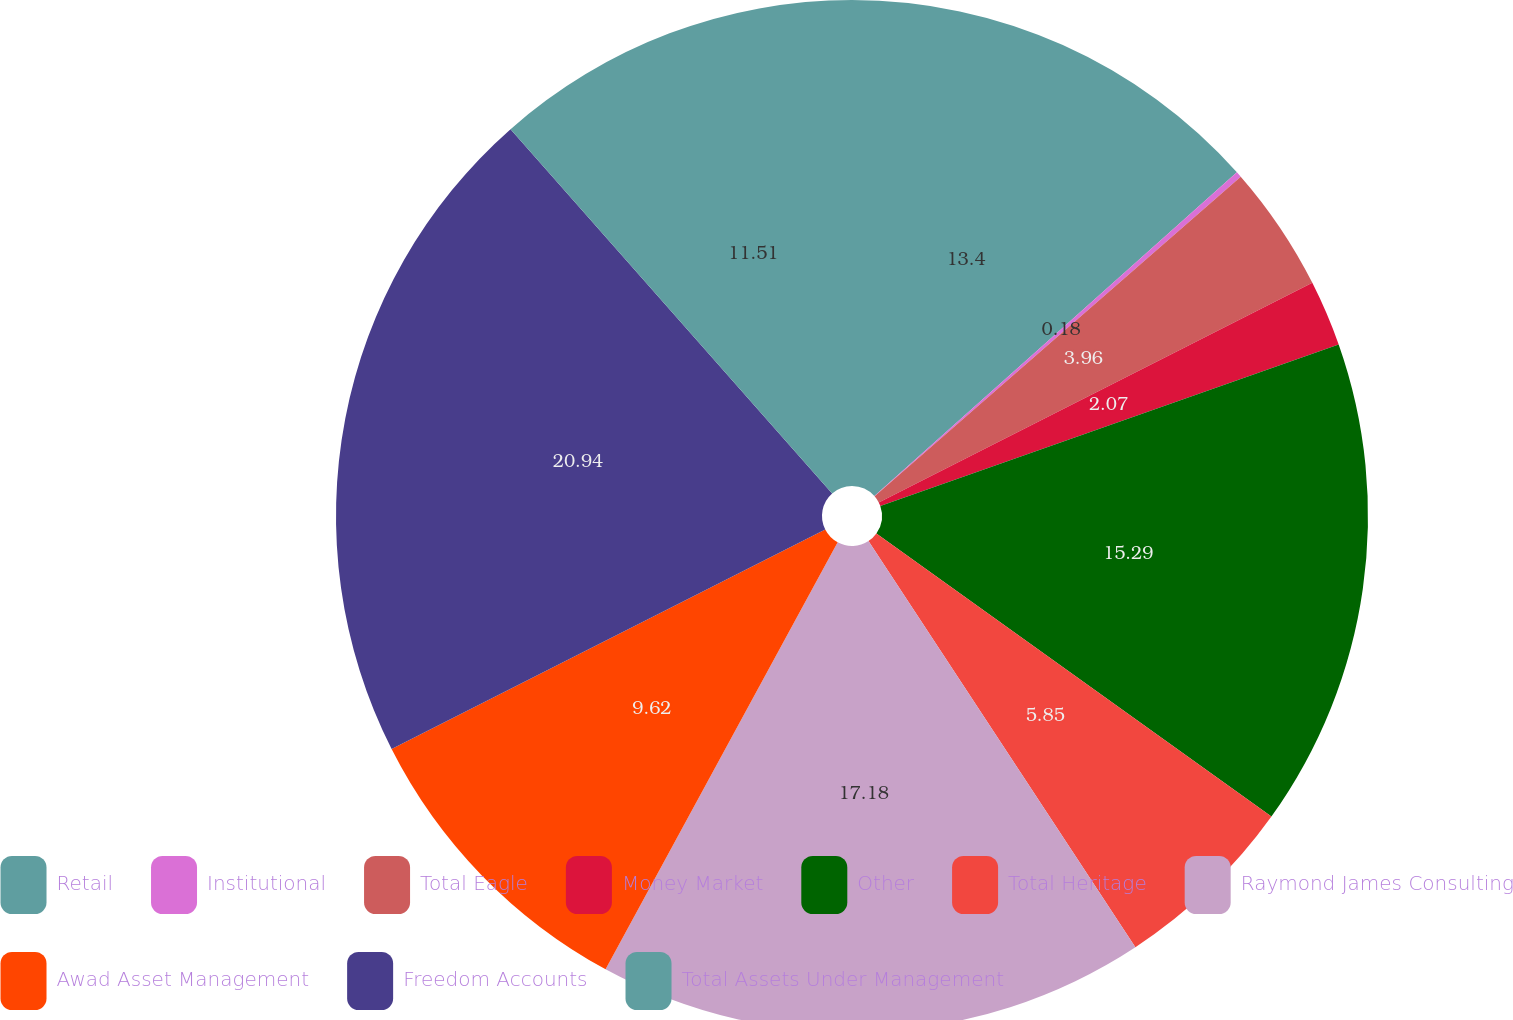Convert chart. <chart><loc_0><loc_0><loc_500><loc_500><pie_chart><fcel>Retail<fcel>Institutional<fcel>Total Eagle<fcel>Money Market<fcel>Other<fcel>Total Heritage<fcel>Raymond James Consulting<fcel>Awad Asset Management<fcel>Freedom Accounts<fcel>Total Assets Under Management<nl><fcel>13.4%<fcel>0.18%<fcel>3.96%<fcel>2.07%<fcel>15.29%<fcel>5.85%<fcel>17.18%<fcel>9.62%<fcel>20.95%<fcel>11.51%<nl></chart> 